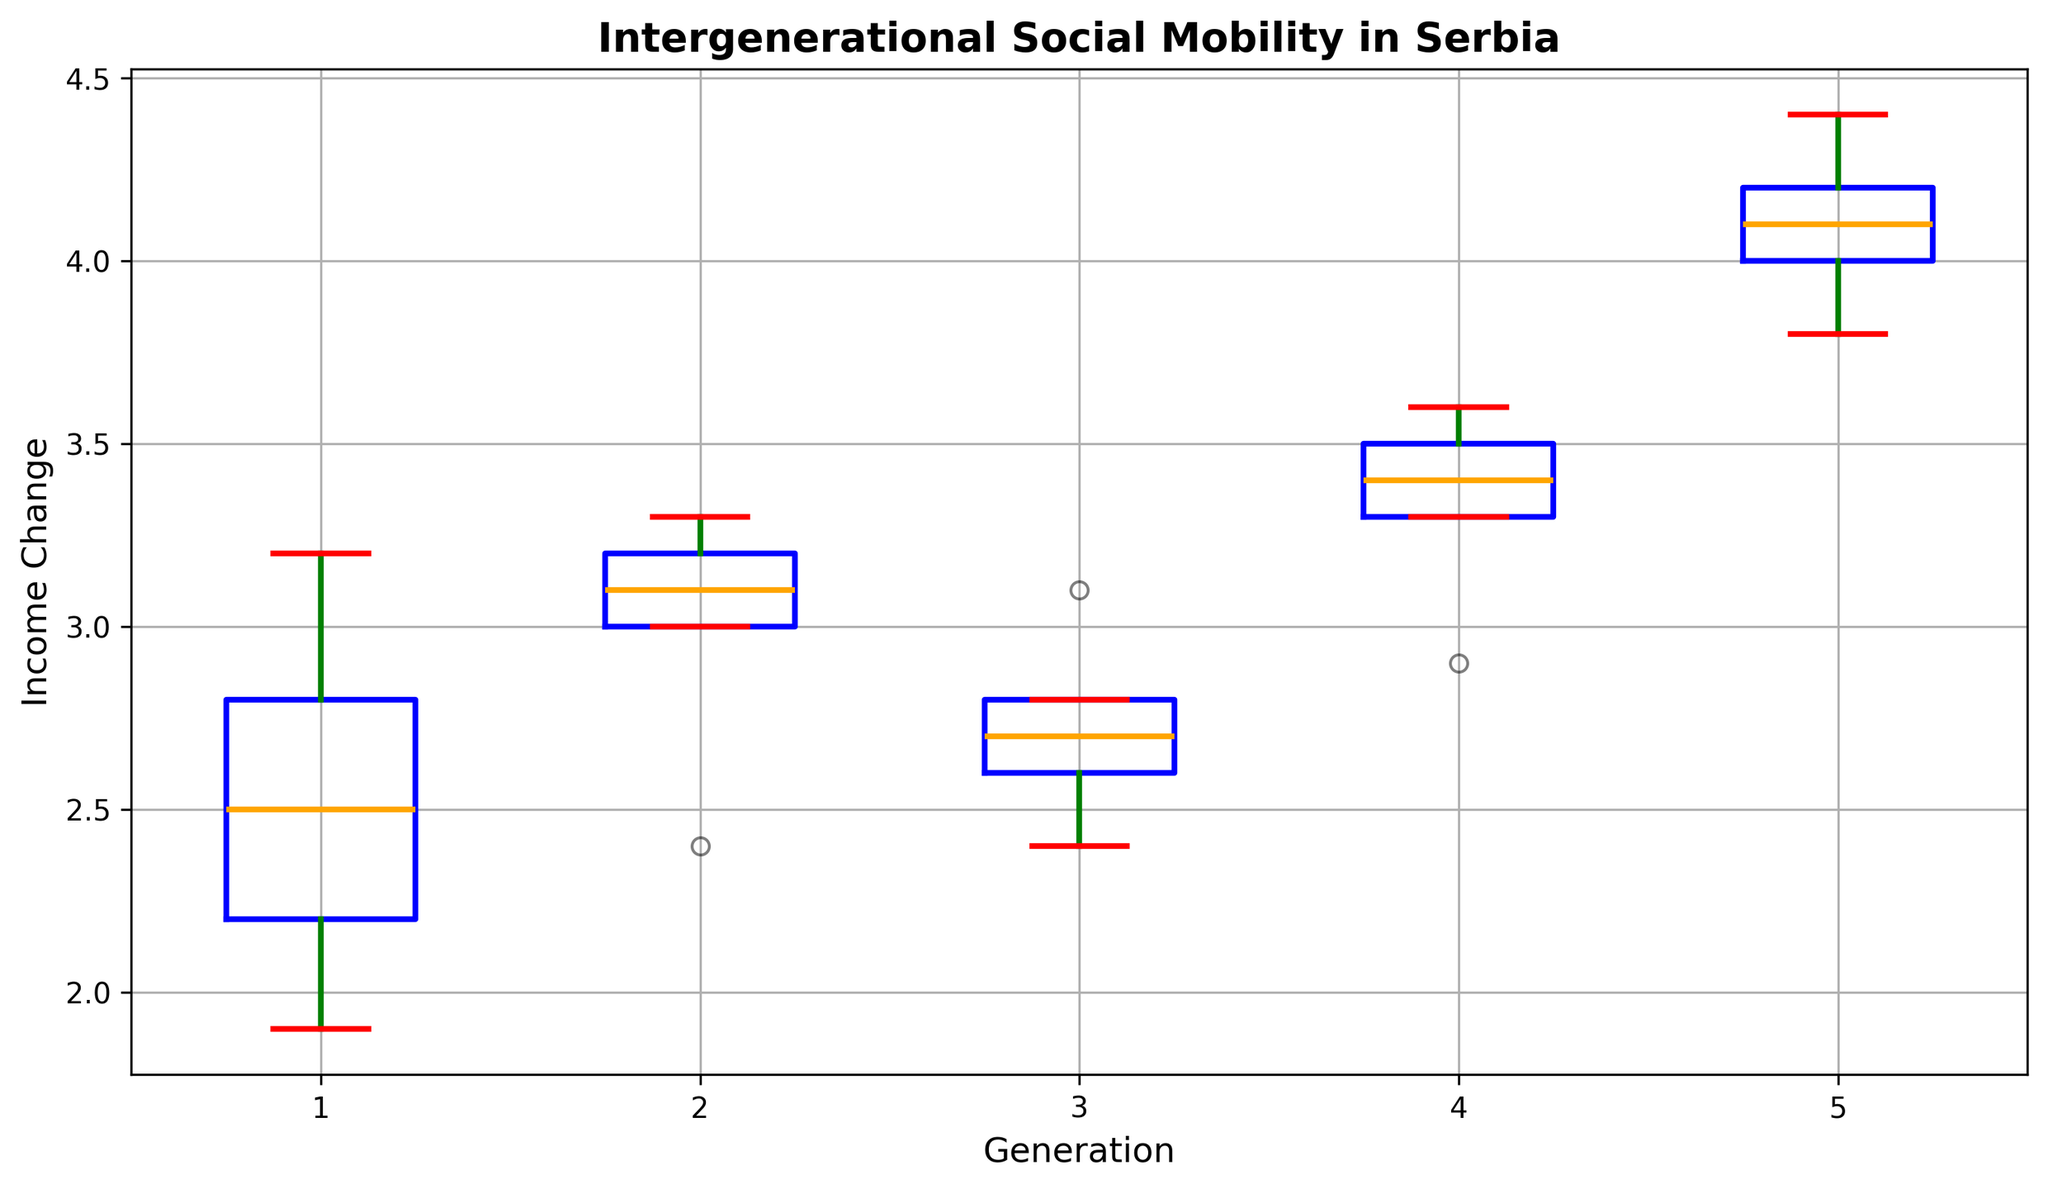What is the median income change for the 3rd generation? To find the median, locate the middle data point of the income changes for the 3rd generation when ordered. The data points are 2.4, 2.6, 2.7, 2.8, and 3.1. The median is the middle value, which is 2.7.
Answer: 2.7 How does the median income change of the 1st generation compare to the 5th generation? The median income change for the 1st generation is the middle value of 1.9, 2.2, 2.5, 2.8, and 3.2, which is 2.5. For the 5th generation, it's the middle value of 3.8, 4.0, 4.1, 4.2, and 4.4, which is 4.1. Comparing them, the 5th generation's median (4.1) is higher than the 1st generation's median (2.5).
Answer: The 5th generation's median is higher Which generation has the smallest range of income changes (from minimum to maximum)? The range is the difference between the maximum and minimum values for each generation. 
1st Gen: 3.2 - 1.9 = 1.3 
2nd Gen: 3.3 - 2.4 = 0.9 
3rd Gen: 3.1 - 2.4 = 0.7 
4th Gen: 3.6 - 2.9 = 0.7 
5th Gen: 4.4 - 3.8 = 0.6 
Comparing the ranges, the 5th generation has the smallest range, which is 0.6.
Answer: 5th generation What can we infer about the outliers in the data? Outliers are typically identified as points beyond the whiskers in a box plot. The absence of outliers in the box plot suggests that all data points fall within the expected range (minimum and maximum values indicated by the whiskers) for each generation.
Answer: No outliers Are the income changes more consistent (less spread out) in the earlier or later generations? Consistency can be inferred from the spread of the boxes and whiskers. Comparing the 1st and 5th generations:
1st Gen: The interquartile range (IQR, difference between the 25th and 75th percentiles, i.e., the height of the box) is larger indicating more spread.
5th Gen: The IQR is smaller showing less spread.
Thus, later generations, especially the 5th generation, show more consistency.
Answer: Later generations 